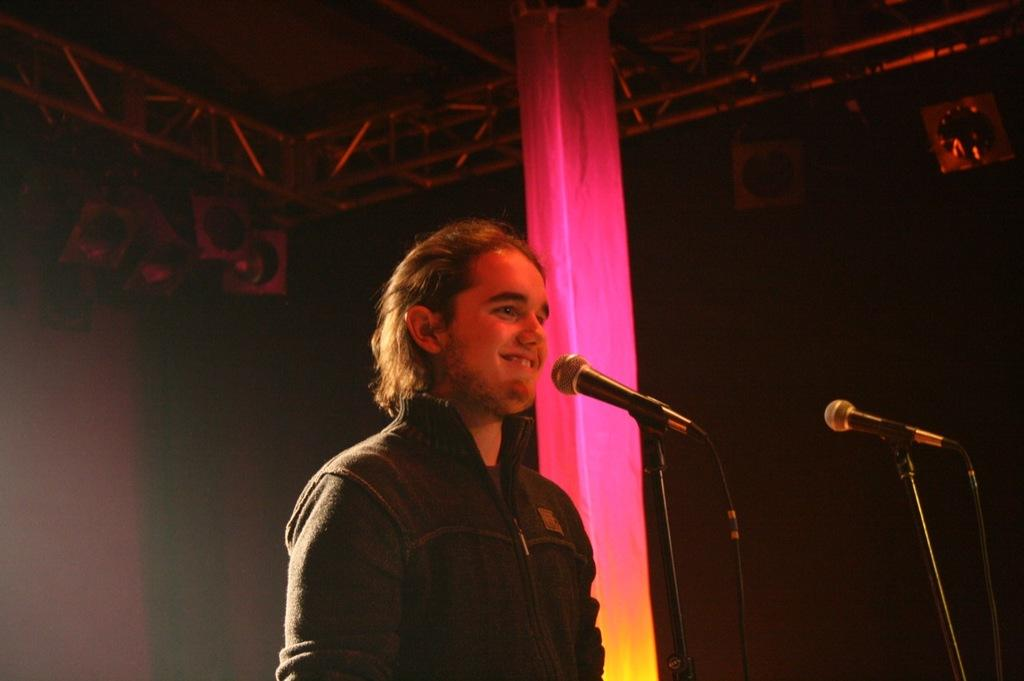What is the person in the image wearing? The person in the image is wearing a jacket. What object can be seen near the person in the image? There is a microphone (mic) in the image. What are the rods visible at the top of the image used for? The purpose of the rods visible at the top of the image is not specified, but they could be part of a structure or equipment. What architectural feature is present in the image? There is a pillar in the image. How does the person in the image control their impulse to produce a wrist-like movement? There is no information about the person's impulses or wrist movements in the image. 